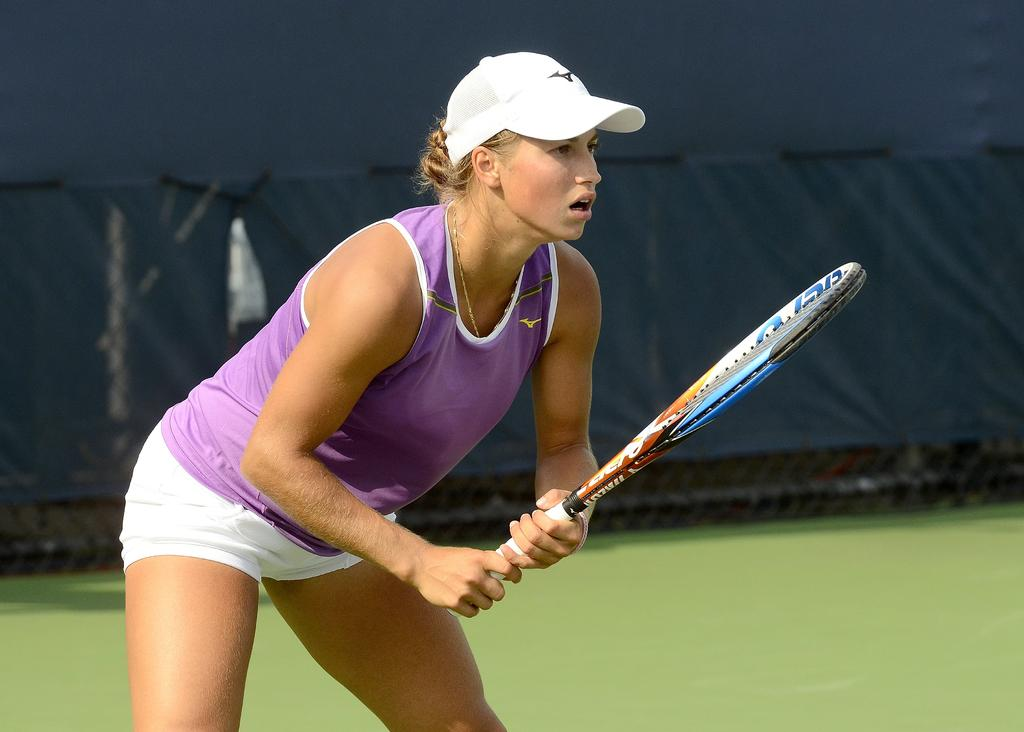Who is present in the image? There is a person in the image. What type of clothing is the person wearing? The person is wearing a sports dress. What activity is the person engaged in? The person is playing tennis. Can you describe the lamp that is present in the image? There is no lamp present in the image; it features a person playing tennis while wearing a sports dress. 